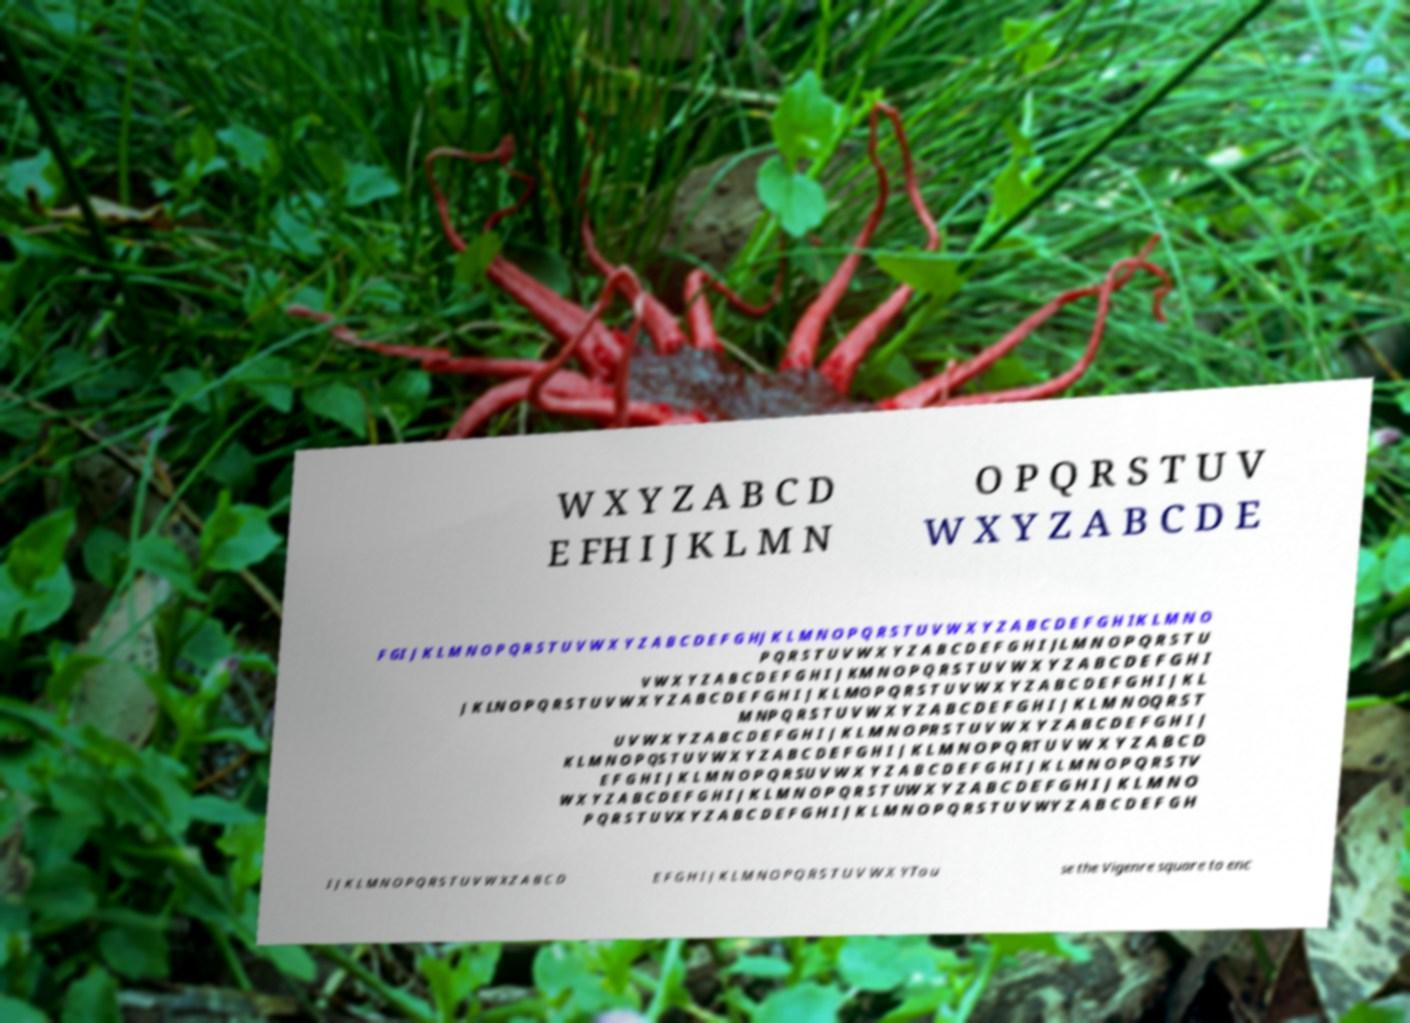Can you read and provide the text displayed in the image?This photo seems to have some interesting text. Can you extract and type it out for me? W X Y Z A B C D E FH I J K L M N O P Q R S T U V W X Y Z A B C D E F GI J K L M N O P Q R S T U V W X Y Z A B C D E F G HJ K L M N O P Q R S T U V W X Y Z A B C D E F G H IK L M N O P Q R S T U V W X Y Z A B C D E F G H I JL M N O P Q R S T U V W X Y Z A B C D E F G H I J KM N O P Q R S T U V W X Y Z A B C D E F G H I J K LN O P Q R S T U V W X Y Z A B C D E F G H I J K L MO P Q R S T U V W X Y Z A B C D E F G H I J K L M NP Q R S T U V W X Y Z A B C D E F G H I J K L M N OQ R S T U V W X Y Z A B C D E F G H I J K L M N O PR S T U V W X Y Z A B C D E F G H I J K L M N O P QS T U V W X Y Z A B C D E F G H I J K L M N O P Q RT U V W X Y Z A B C D E F G H I J K L M N O P Q R SU V W X Y Z A B C D E F G H I J K L M N O P Q R S TV W X Y Z A B C D E F G H I J K L M N O P Q R S T UW X Y Z A B C D E F G H I J K L M N O P Q R S T U VX Y Z A B C D E F G H I J K L M N O P Q R S T U V WY Z A B C D E F G H I J K L M N O P Q R S T U V W XZ A B C D E F G H I J K L M N O P Q R S T U V W X YTo u se the Vigenre square to enc 